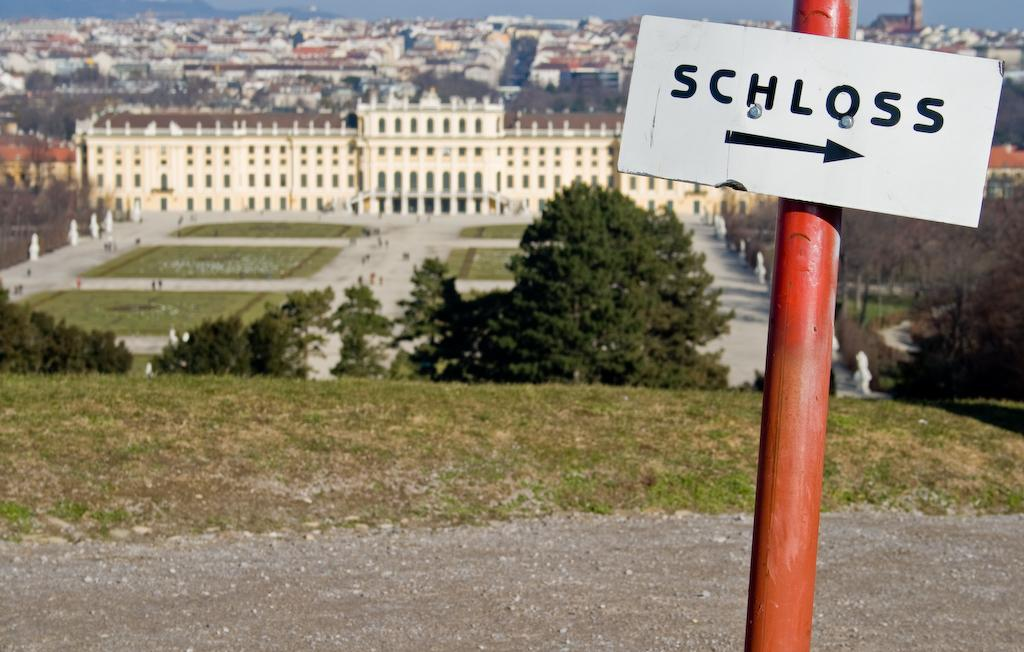Provide a one-sentence caption for the provided image. A sign on a red post labelled SCHLOSS. 